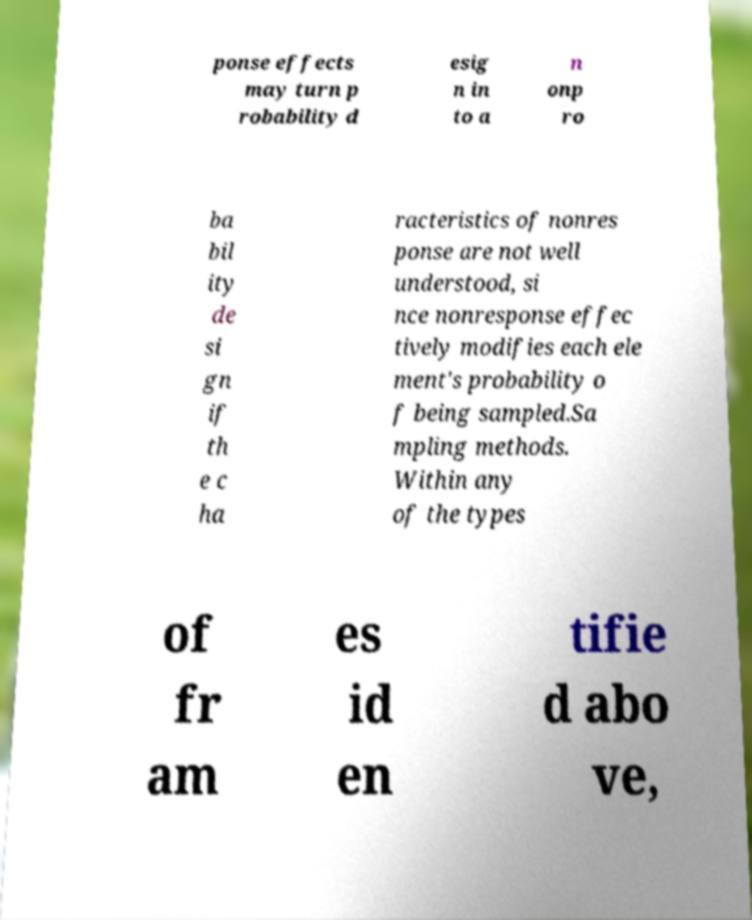Could you extract and type out the text from this image? ponse effects may turn p robability d esig n in to a n onp ro ba bil ity de si gn if th e c ha racteristics of nonres ponse are not well understood, si nce nonresponse effec tively modifies each ele ment's probability o f being sampled.Sa mpling methods. Within any of the types of fr am es id en tifie d abo ve, 